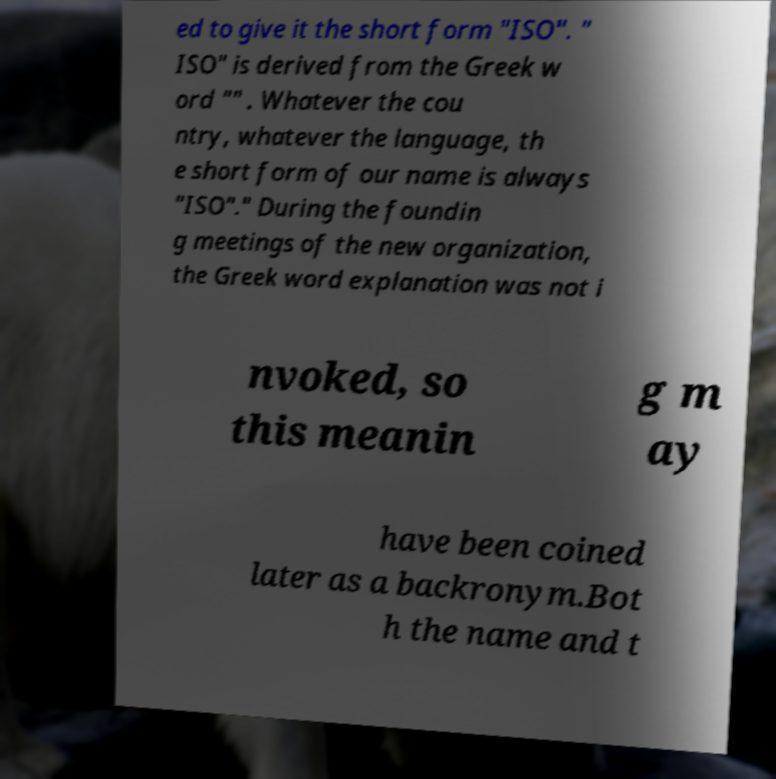Could you assist in decoding the text presented in this image and type it out clearly? ed to give it the short form "ISO". " ISO" is derived from the Greek w ord "" . Whatever the cou ntry, whatever the language, th e short form of our name is always "ISO"." During the foundin g meetings of the new organization, the Greek word explanation was not i nvoked, so this meanin g m ay have been coined later as a backronym.Bot h the name and t 